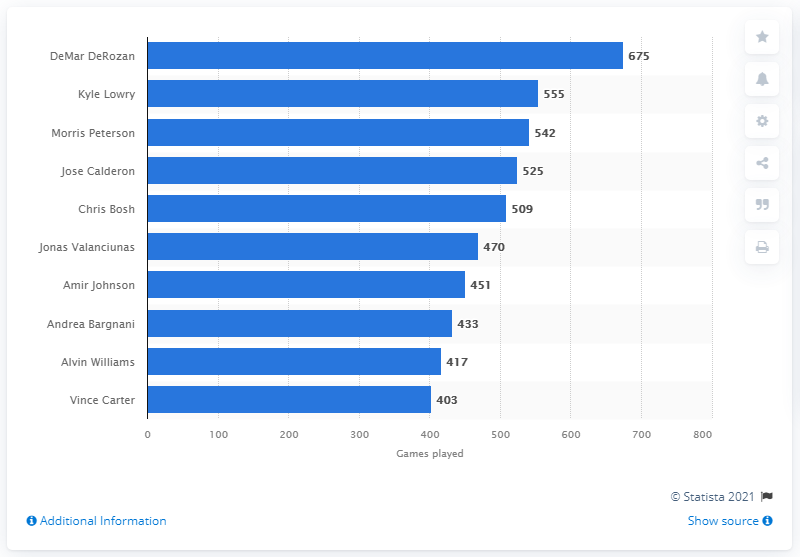Draw attention to some important aspects in this diagram. DeMar DeRozan is the career games played leader of the Toronto Raptors. DeMar DeRozan has played a total of 675 games. 